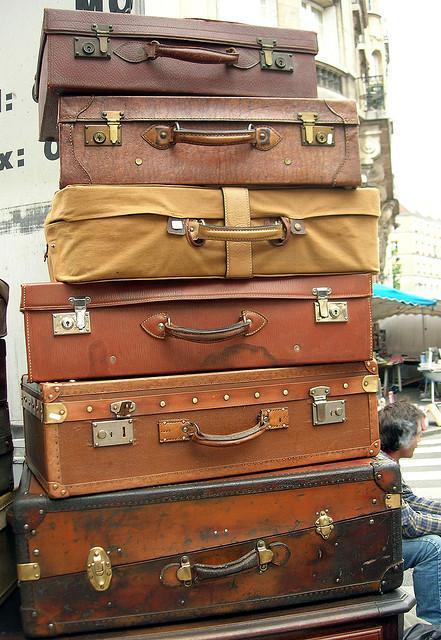How many black briefcases?
Give a very brief answer. 0. How many suitcases are there?
Give a very brief answer. 6. 